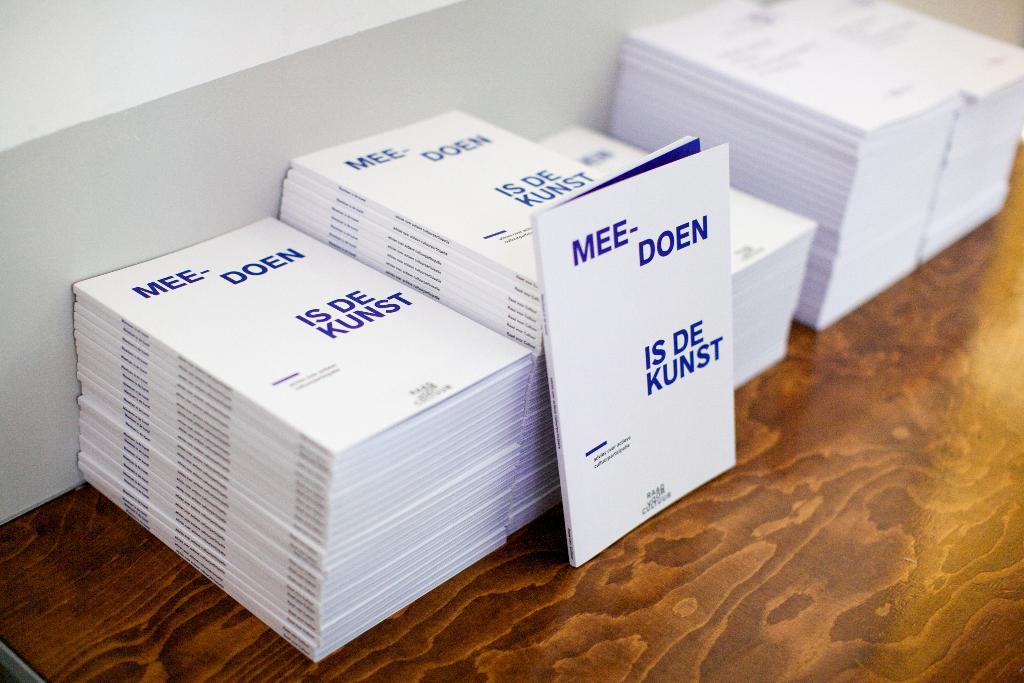What is the name of this book?
Keep it short and to the point. Mee-doen. Who wrote this book?
Provide a short and direct response. Mee doen. 